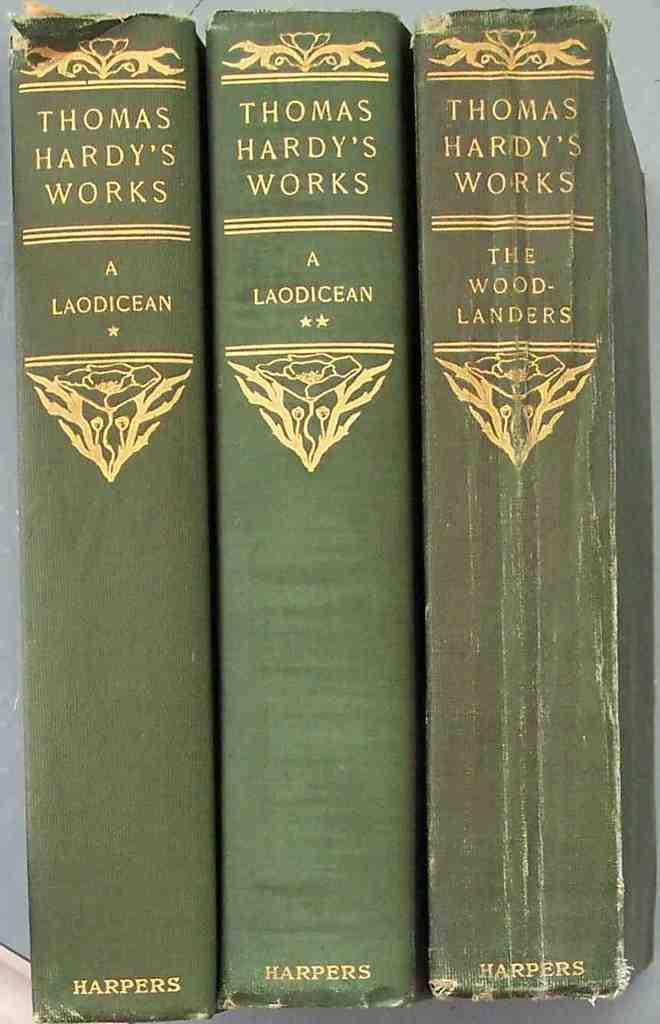<image>
Provide a brief description of the given image. Three books of Thomas Hardy's work are lined up with the spines visible. 